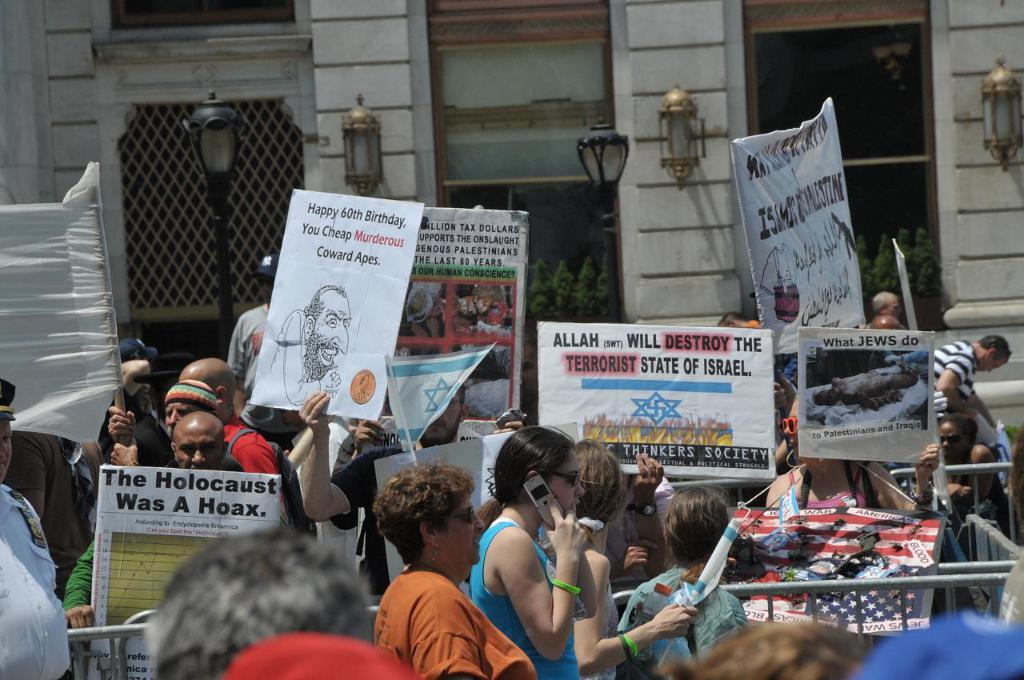What is happening in the foreground of the image? There is a crowd on the road in the foreground, and there are posters and a fence present as well. Can you describe the background of the image? In the background, there is a building, light poles, and houseplants visible. What can be inferred about the time of day when the image was taken? The image is likely taken during the day, as there is sufficient light to see the details clearly. Where is the market located in the image? There is no market present in the image. What is the level of humor in the image? The image does not convey any humor; it is a straightforward depiction of a scene. 